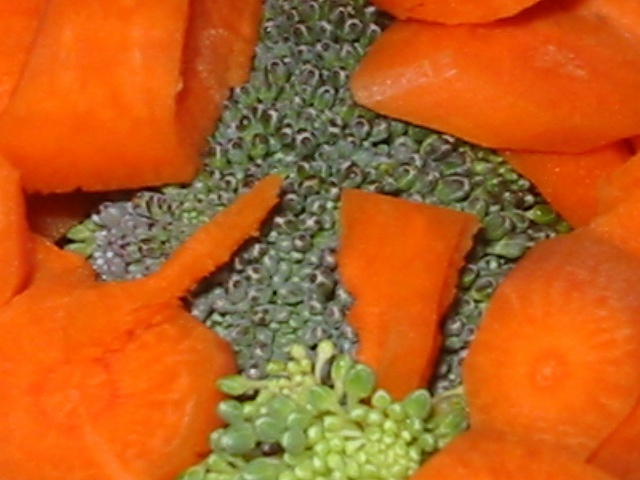Describe the objects in this image and their specific colors. I can see broccoli in red, gray, darkgreen, and olive tones, carrot in red and brown tones, carrot in red and brown tones, carrot in red and brown tones, and carrot in red, brown, and maroon tones in this image. 